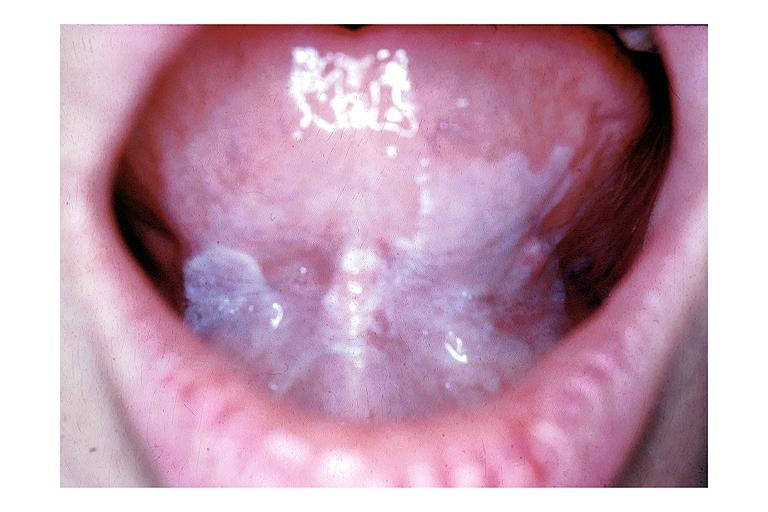what does this image show?
Answer the question using a single word or phrase. Leukoplakia 